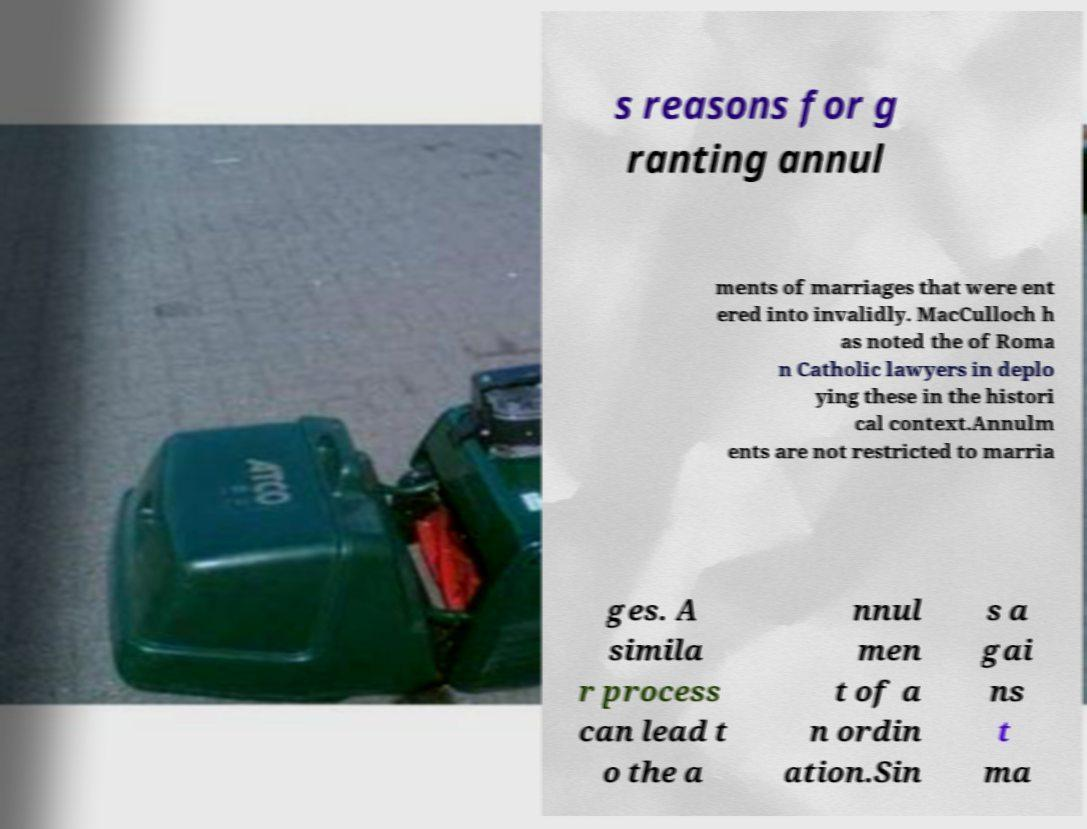Please identify and transcribe the text found in this image. s reasons for g ranting annul ments of marriages that were ent ered into invalidly. MacCulloch h as noted the of Roma n Catholic lawyers in deplo ying these in the histori cal context.Annulm ents are not restricted to marria ges. A simila r process can lead t o the a nnul men t of a n ordin ation.Sin s a gai ns t ma 